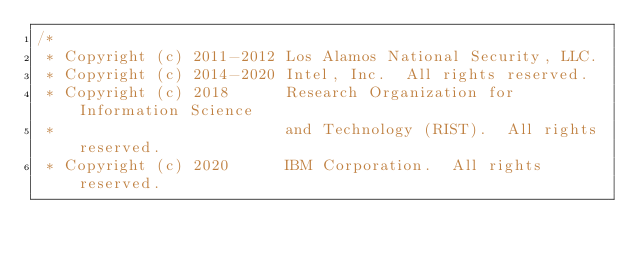<code> <loc_0><loc_0><loc_500><loc_500><_C_>/*
 * Copyright (c) 2011-2012 Los Alamos National Security, LLC.
 * Copyright (c) 2014-2020 Intel, Inc.  All rights reserved.
 * Copyright (c) 2018      Research Organization for Information Science
 *                         and Technology (RIST).  All rights reserved.
 * Copyright (c) 2020      IBM Corporation.  All rights reserved.</code> 